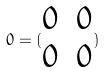Convert formula to latex. <formula><loc_0><loc_0><loc_500><loc_500>0 = ( \begin{matrix} 0 & 0 \\ 0 & 0 \end{matrix} )</formula> 